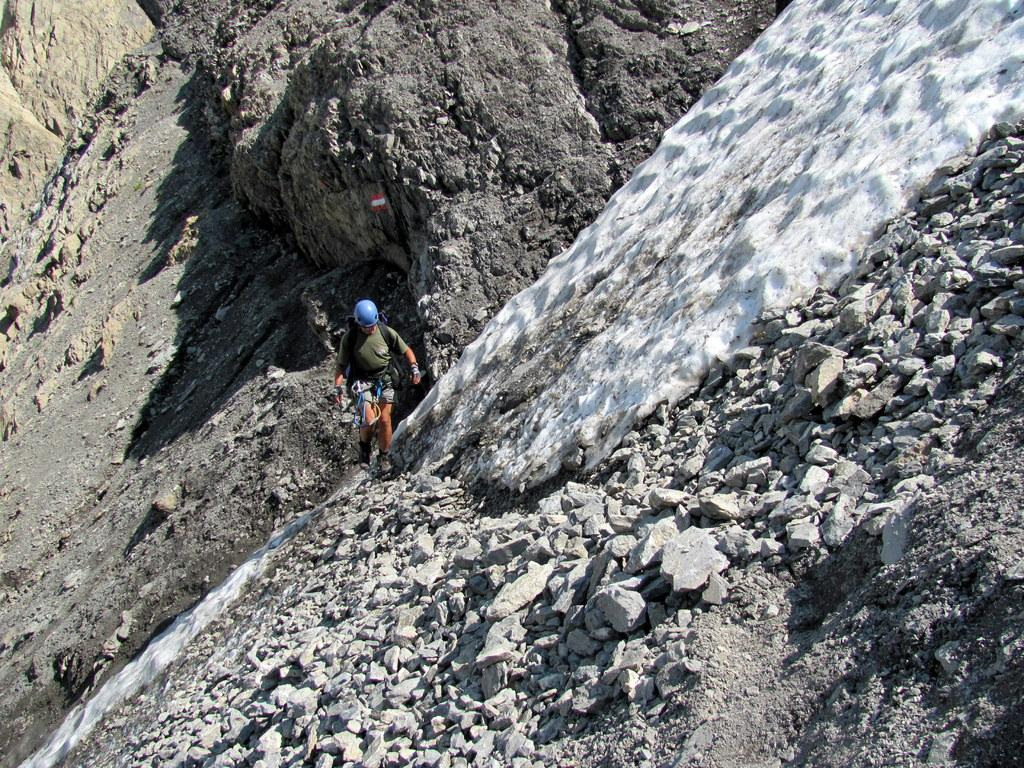Who or what is the main subject in the center of the image? There is a person in the center of the image. What is the person wearing on their body? The person is wearing a bag. What type of protective gear is the person wearing on their head? The person is wearing a helmet. What can be seen in the background of the image? There are rocks in the background of the image. How many legs can be seen on the cattle in the image? There are no cattle present in the image, so it is not possible to determine the number of legs. 